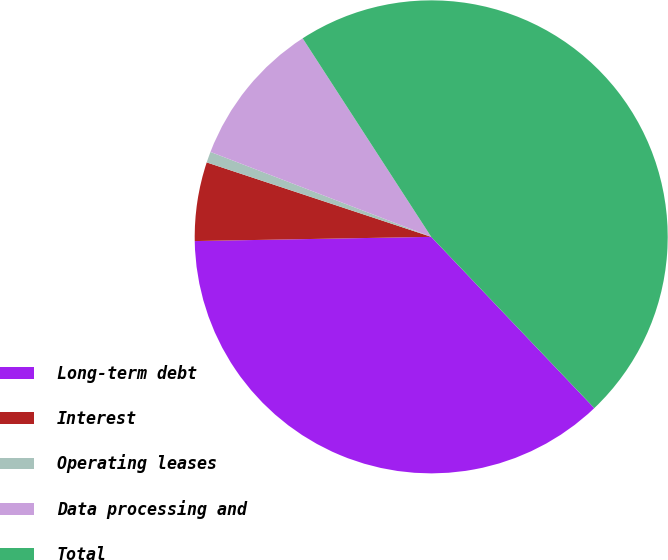Convert chart. <chart><loc_0><loc_0><loc_500><loc_500><pie_chart><fcel>Long-term debt<fcel>Interest<fcel>Operating leases<fcel>Data processing and<fcel>Total<nl><fcel>36.83%<fcel>5.38%<fcel>0.75%<fcel>10.01%<fcel>47.04%<nl></chart> 